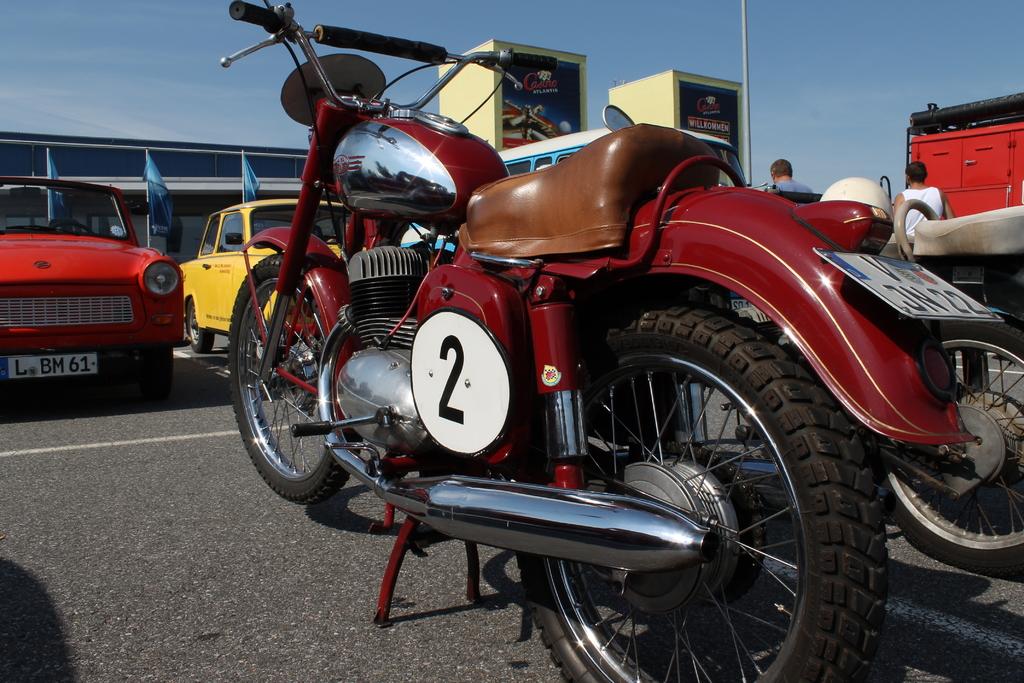What number is the bike?
Make the answer very short. 2. Whats the license plate number on the red car?
Provide a succinct answer. L bm 61. 